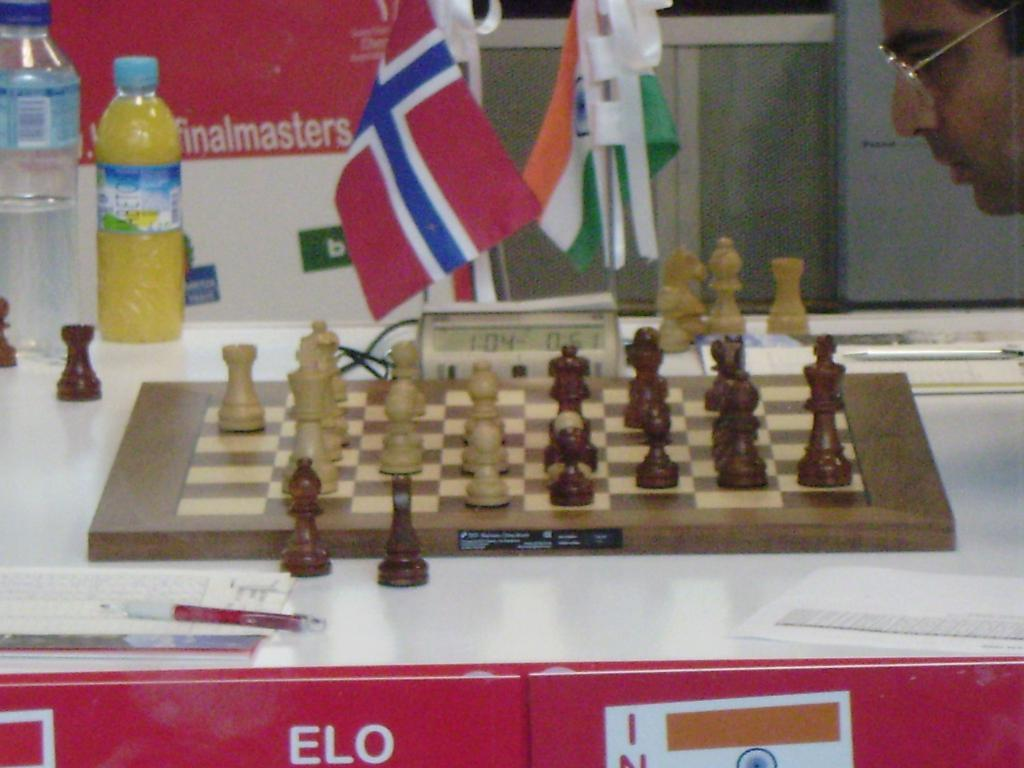<image>
Write a terse but informative summary of the picture. A chess game is being played at the finalmasters tournament. 